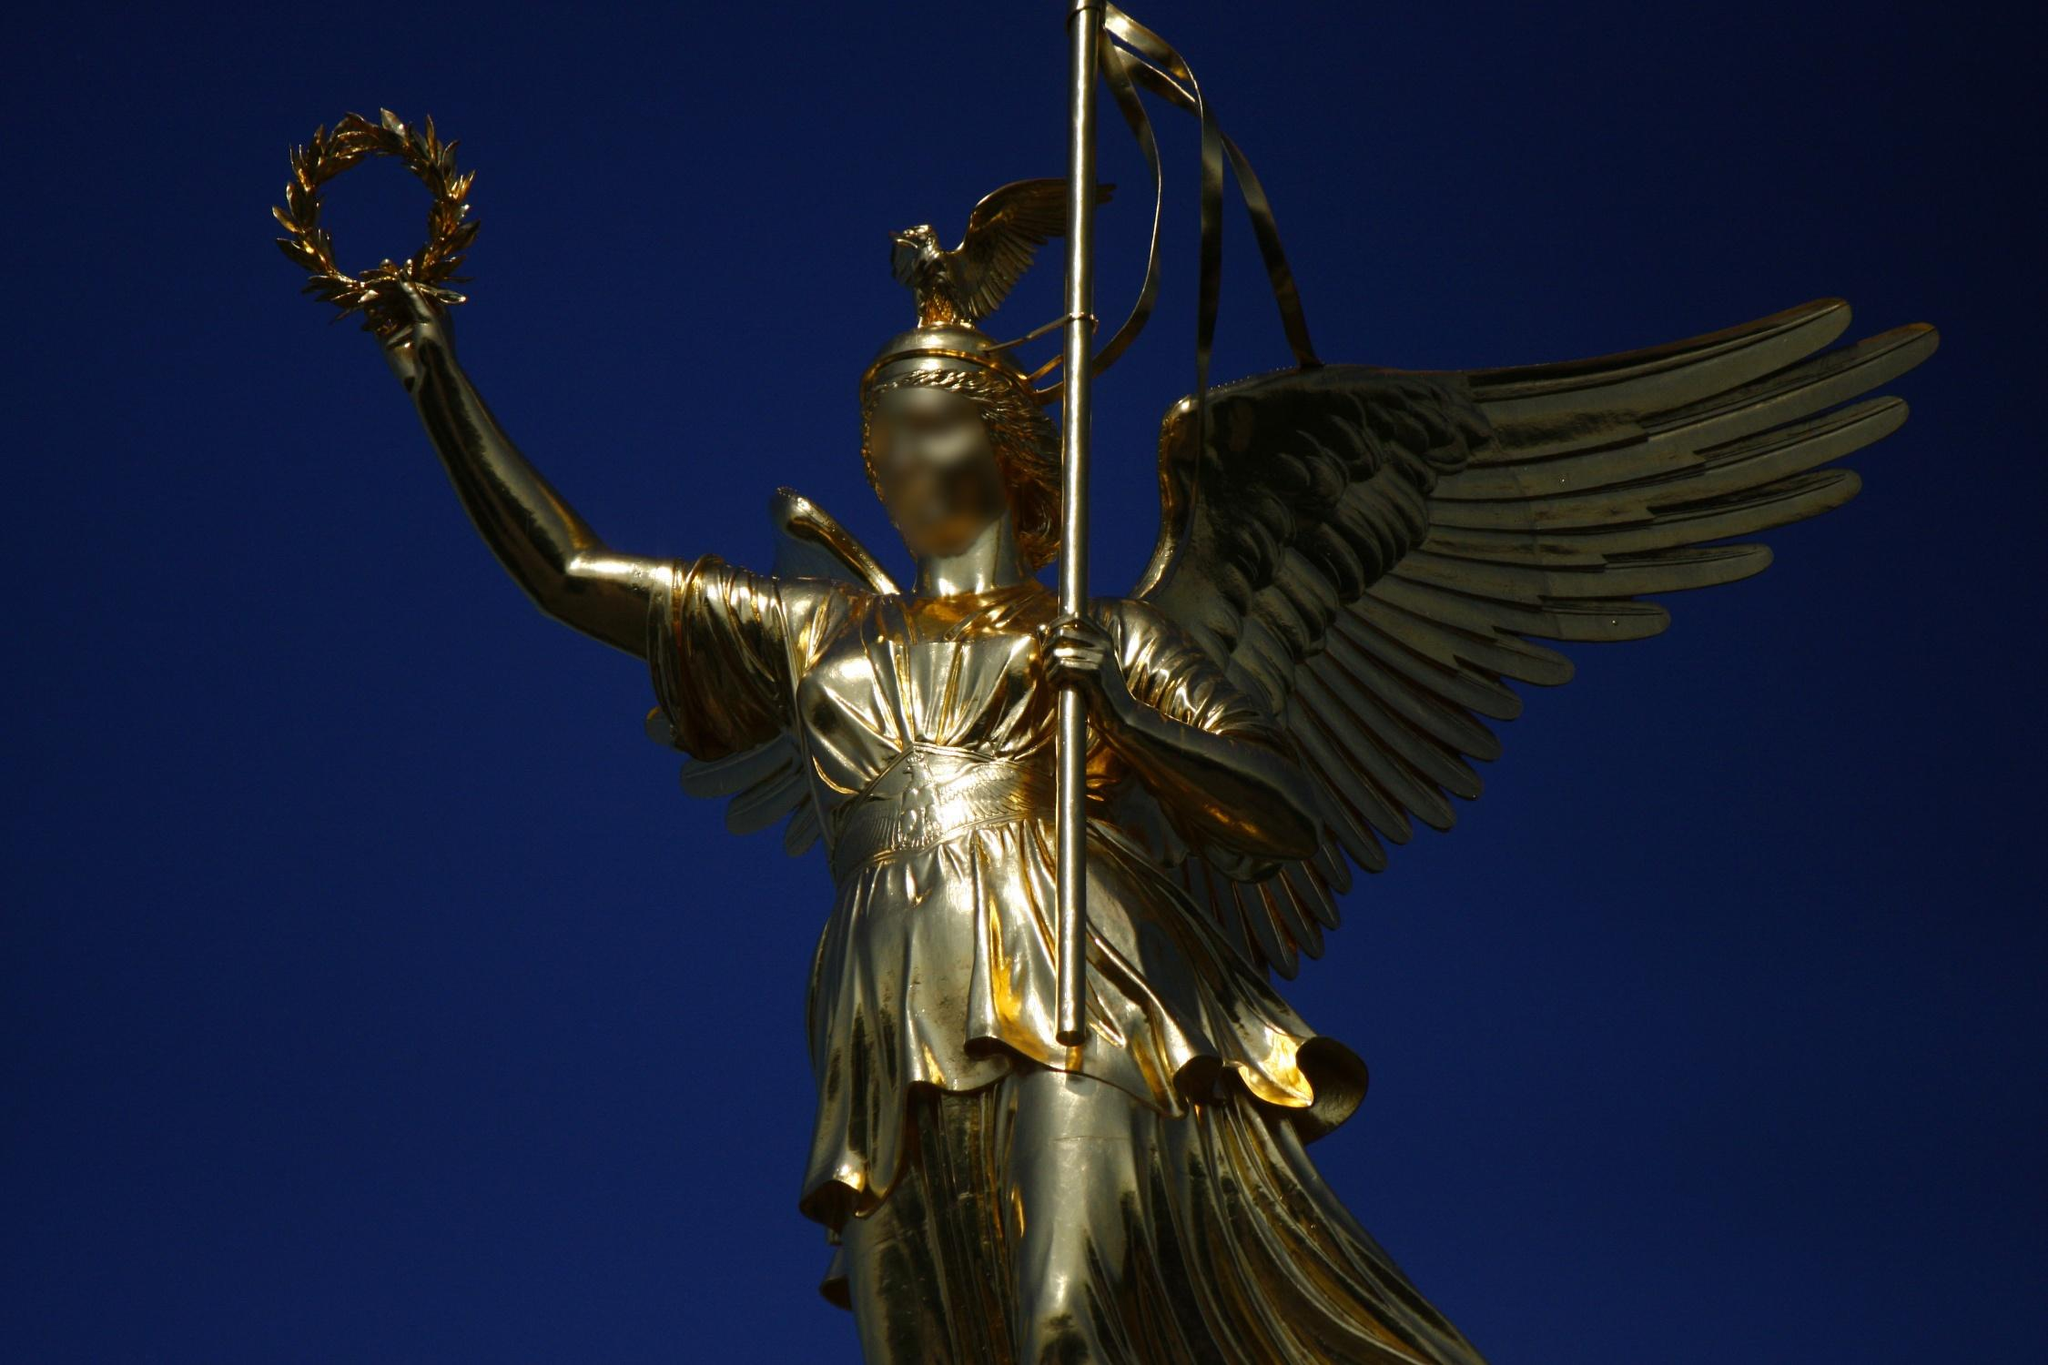Tell a story about a day in the life of the statue’s creator. On a crisp autumn morning in the studio, the sculptor awoke with a vivid inspiration for Victoria's statue. His fingers danced along the raw bronze, shaping the goddess’ form with meticulous care. Every chisel stroke felt like a heartbeat, as if he was breathing life into the metal. Amidst the flurry of tools and sketches, he envisioned the gleam of gold leaf that would later cloak her, symbolizing eternal victory. As dusk settled, he stood back, his hands weary but his spirit invigorated, witnessing the goddess take form, knowing she would inspire generations to come. 